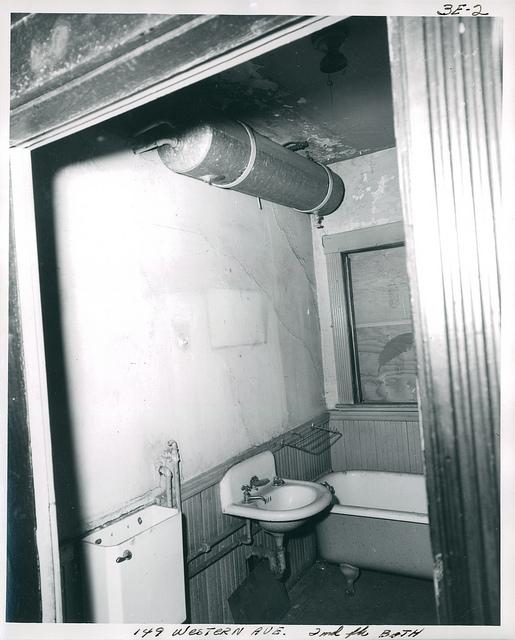How many sinks are there?
Be succinct. 1. Is there a shower?
Short answer required. No. Does this bathroom look modern?
Concise answer only. No. What is on the ceiling?
Keep it brief. Tank. What side of the room is the bathtub?
Keep it brief. Right. 